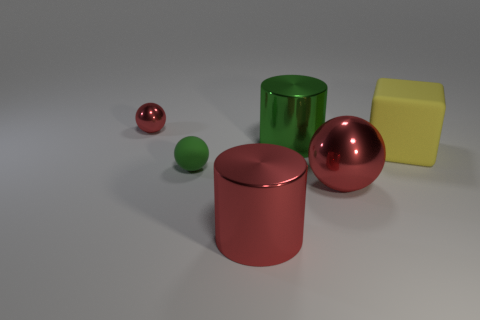Add 4 big cubes. How many objects exist? 10 Subtract all red shiny spheres. How many spheres are left? 1 Subtract all gray spheres. Subtract all yellow cubes. How many spheres are left? 3 Subtract all cylinders. How many objects are left? 4 Add 5 blue shiny cylinders. How many blue shiny cylinders exist? 5 Subtract 1 yellow cubes. How many objects are left? 5 Subtract all red balls. Subtract all rubber spheres. How many objects are left? 3 Add 2 big red shiny balls. How many big red shiny balls are left? 3 